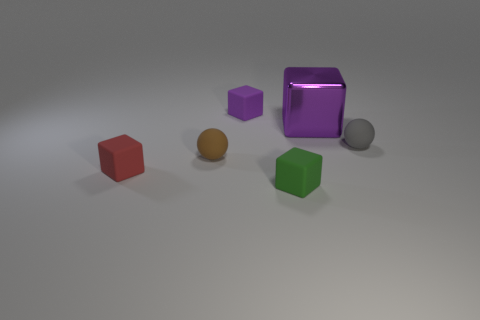What material is the brown object that is the same shape as the gray rubber thing?
Provide a succinct answer. Rubber. There is a rubber block that is both in front of the small purple thing and to the right of the brown thing; what is its size?
Keep it short and to the point. Small. There is a ball that is the same size as the gray matte object; what is it made of?
Ensure brevity in your answer.  Rubber. The green thing that is the same size as the brown object is what shape?
Give a very brief answer. Cube. Is the number of small gray balls that are behind the metallic block less than the number of tiny purple things that are in front of the tiny purple rubber block?
Offer a terse response. No. Does the small thing that is behind the gray ball have the same shape as the gray matte thing?
Ensure brevity in your answer.  No. There is a ball that is the same material as the brown object; what color is it?
Keep it short and to the point. Gray. How many small objects have the same material as the tiny purple block?
Your response must be concise. 4. What color is the tiny rubber sphere to the right of the rubber ball on the left side of the tiny matte cube behind the gray sphere?
Keep it short and to the point. Gray. Is the size of the green block the same as the gray matte sphere?
Give a very brief answer. Yes. 